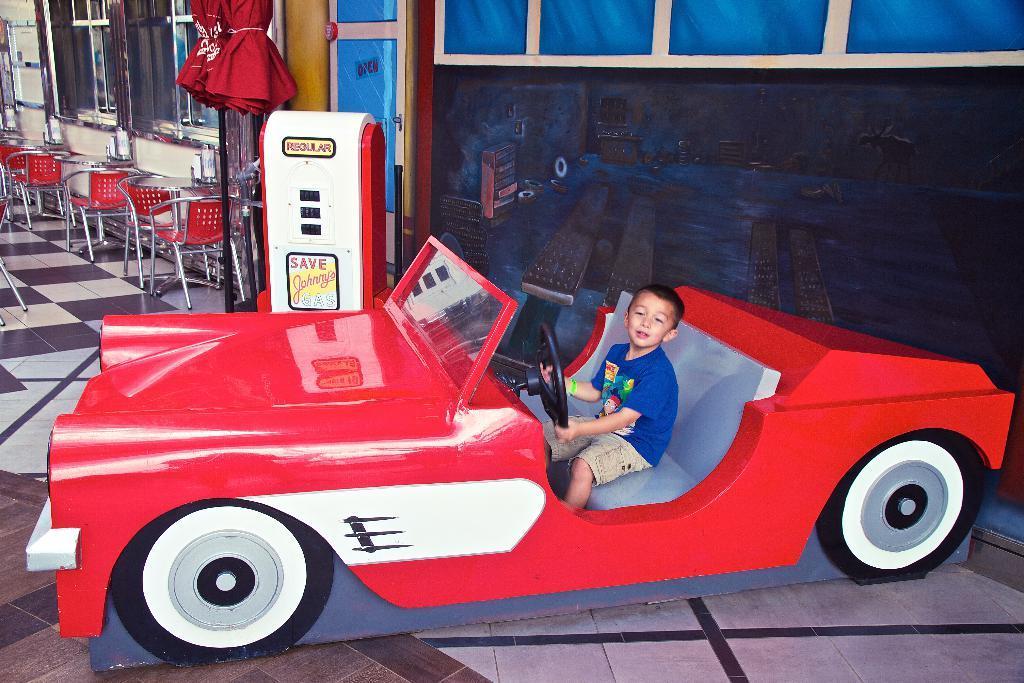Please provide a concise description of this image. In this image, we can see a car and there is a kid sitting in the car. We can see some chairs and we can see the windows. 